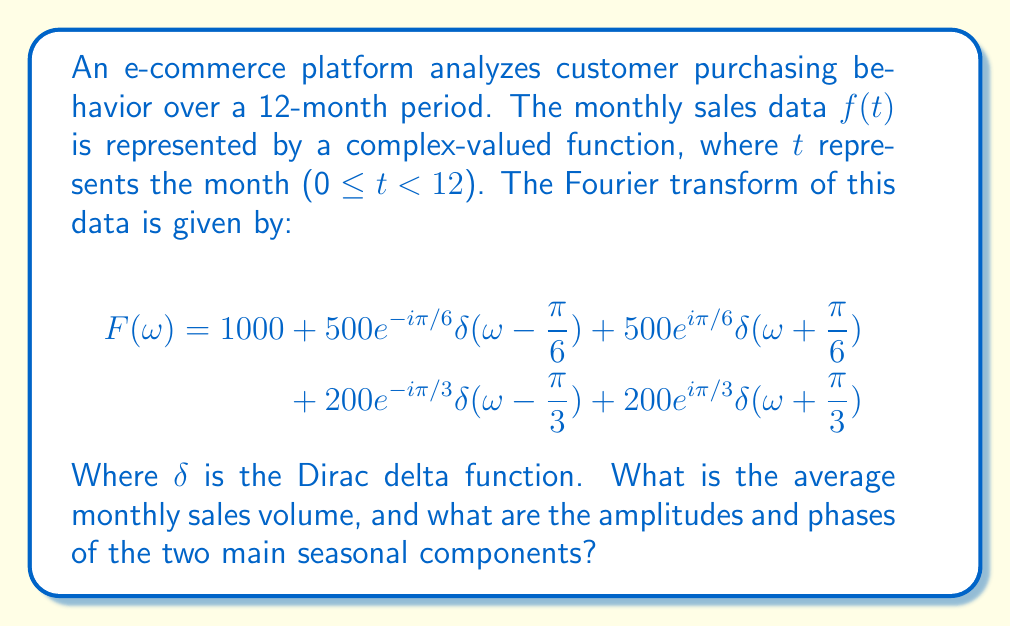Solve this math problem. To solve this problem, we need to interpret the Fourier transform:

1. Average monthly sales:
   The constant term in the Fourier transform represents the average value of the function. Here, it's 1000.

2. Seasonal components:
   The Fourier transform shows two main frequency components:
   a) $\omega = \pm\frac{\pi}{6}$ (corresponding to a 12-month cycle)
   b) $\omega = \pm\frac{\pi}{3}$ (corresponding to a 6-month cycle)

3. For $\omega = \pm\frac{\pi}{6}$:
   Amplitude: $|500e^{-i\pi/6}| = 500$
   Phase: $\arg(500e^{-i\pi/6}) = -\frac{\pi}{6}$ radians or -30°

4. For $\omega = \pm\frac{\pi}{3}$:
   Amplitude: $|200e^{-i\pi/3}| = 200$
   Phase: $\arg(200e^{-i\pi/3}) = -\frac{\pi}{3}$ radians or -60°

The negative phases indicate that these components lag behind a cosine wave of the same frequency.
Answer: Average: $1000; Main components: (500, -30°) and (200, -60°) 